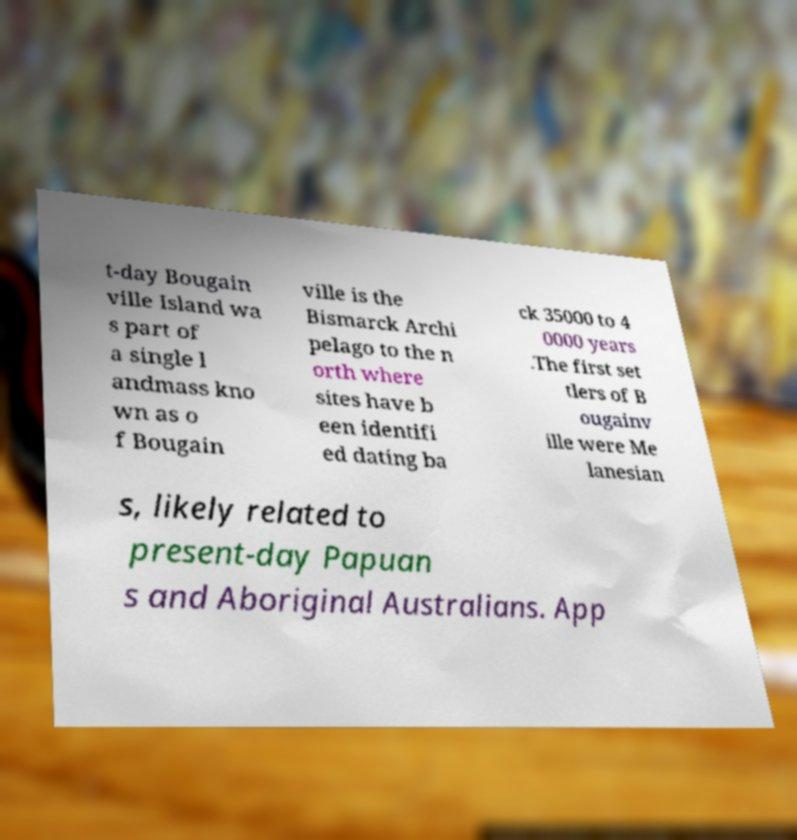Can you accurately transcribe the text from the provided image for me? t-day Bougain ville Island wa s part of a single l andmass kno wn as o f Bougain ville is the Bismarck Archi pelago to the n orth where sites have b een identifi ed dating ba ck 35000 to 4 0000 years .The first set tlers of B ougainv ille were Me lanesian s, likely related to present-day Papuan s and Aboriginal Australians. App 